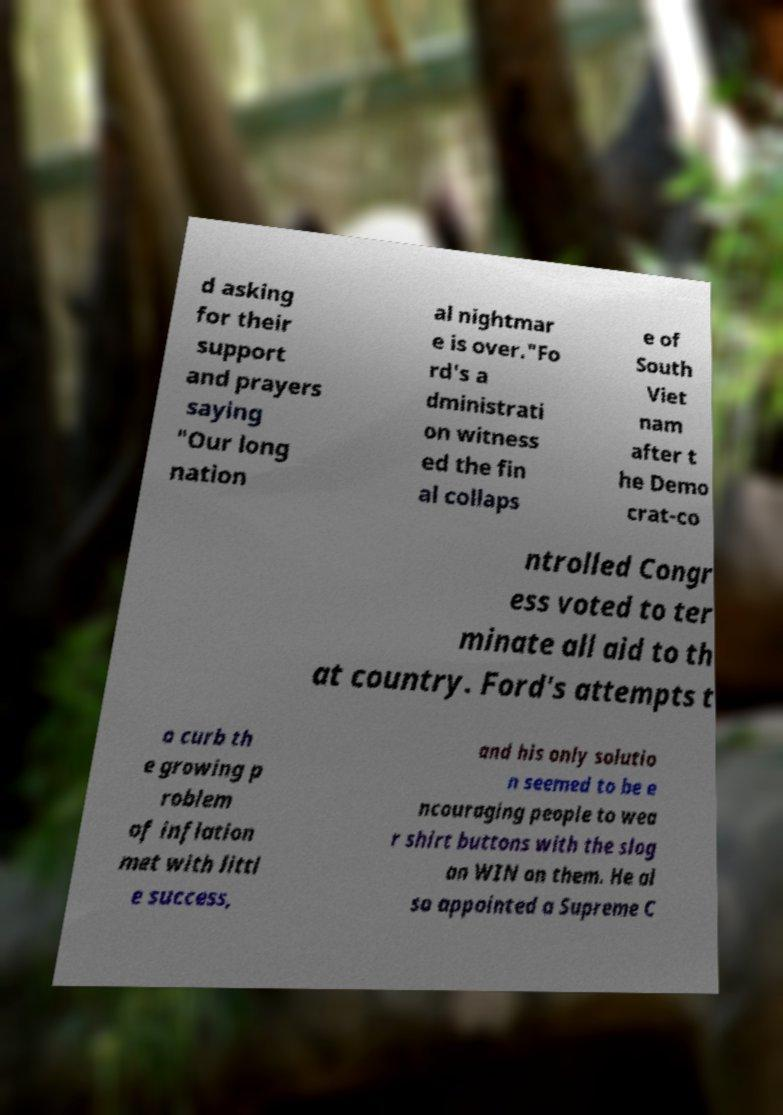I need the written content from this picture converted into text. Can you do that? d asking for their support and prayers saying "Our long nation al nightmar e is over."Fo rd's a dministrati on witness ed the fin al collaps e of South Viet nam after t he Demo crat-co ntrolled Congr ess voted to ter minate all aid to th at country. Ford's attempts t o curb th e growing p roblem of inflation met with littl e success, and his only solutio n seemed to be e ncouraging people to wea r shirt buttons with the slog an WIN on them. He al so appointed a Supreme C 